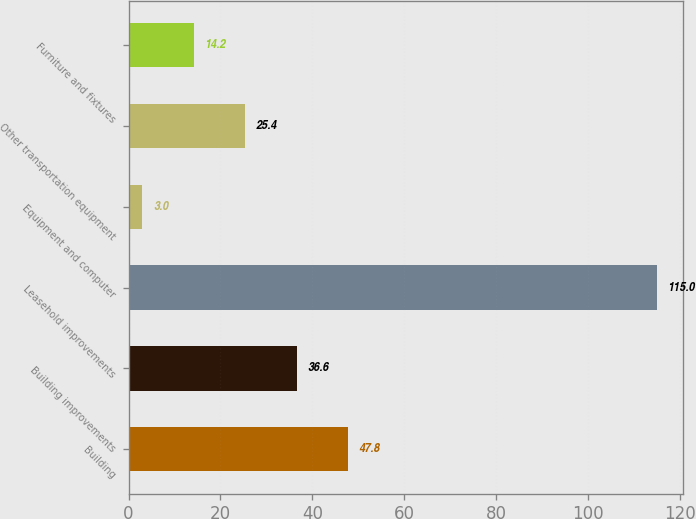Convert chart. <chart><loc_0><loc_0><loc_500><loc_500><bar_chart><fcel>Building<fcel>Building improvements<fcel>Leasehold improvements<fcel>Equipment and computer<fcel>Other transportation equipment<fcel>Furniture and fixtures<nl><fcel>47.8<fcel>36.6<fcel>115<fcel>3<fcel>25.4<fcel>14.2<nl></chart> 